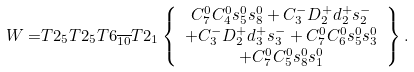<formula> <loc_0><loc_0><loc_500><loc_500>W = & T 2 _ { 5 } T 2 _ { 5 } T 6 _ { \overline { 1 0 } } T 2 _ { 1 } \left \{ \begin{array} { c } C ^ { 0 } _ { 7 } C ^ { 0 } _ { 4 } s ^ { 0 } _ { 5 } s ^ { 0 } _ { 8 } + C ^ { - } _ { 3 } D ^ { + } _ { 2 } d ^ { + } _ { 2 } s ^ { - } _ { 2 } \\ + C ^ { - } _ { 3 } D ^ { + } _ { 2 } d ^ { + } _ { 3 } s ^ { - } _ { 3 } + C ^ { 0 } _ { 7 } C ^ { 0 } _ { 6 } s ^ { 0 } _ { 5 } s ^ { 0 } _ { 3 } \\ + C ^ { 0 } _ { 7 } C ^ { 0 } _ { 5 } s ^ { 0 } _ { 8 } s ^ { 0 } _ { 1 } \end{array} \right \} .</formula> 